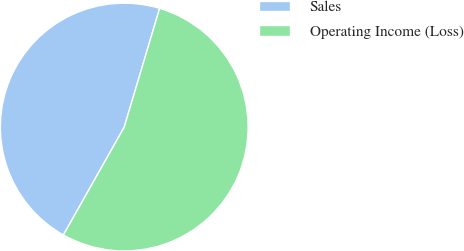Convert chart to OTSL. <chart><loc_0><loc_0><loc_500><loc_500><pie_chart><fcel>Sales<fcel>Operating Income (Loss)<nl><fcel>46.44%<fcel>53.56%<nl></chart> 